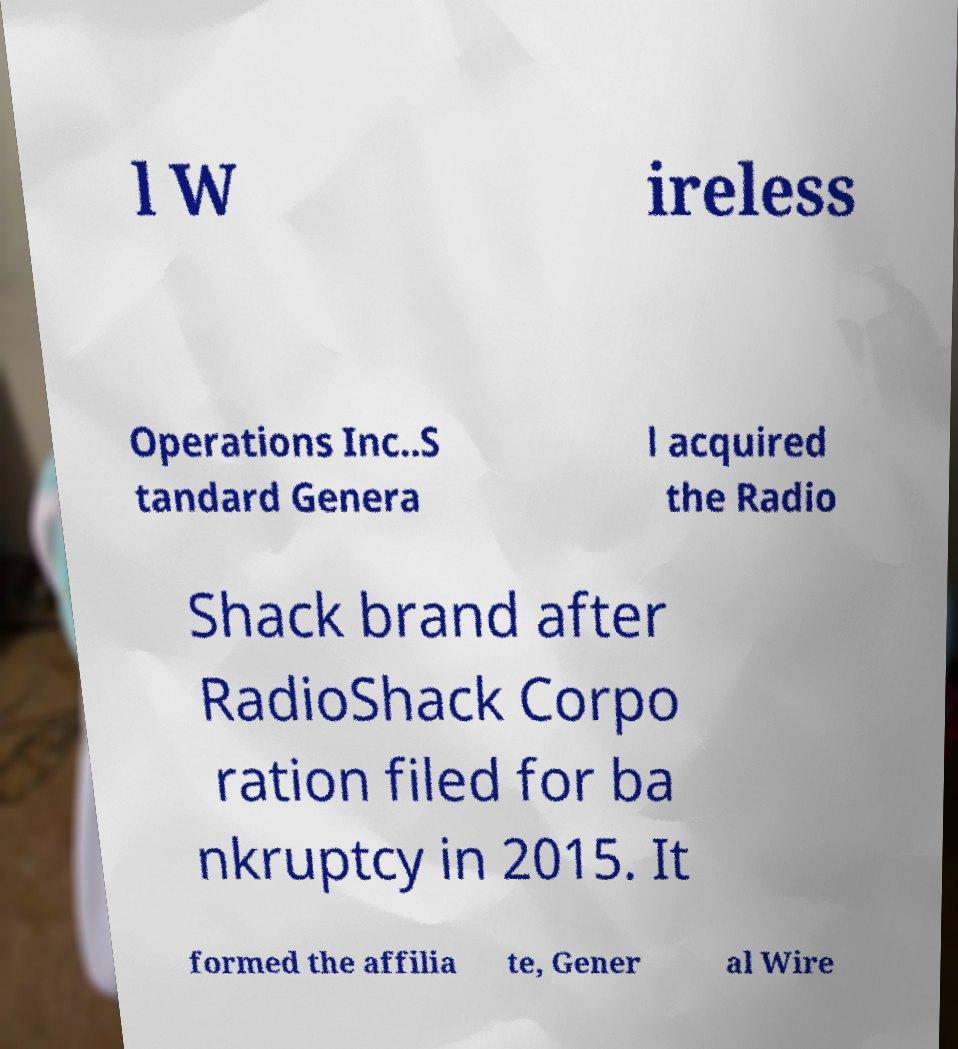Please read and relay the text visible in this image. What does it say? l W ireless Operations Inc..S tandard Genera l acquired the Radio Shack brand after RadioShack Corpo ration filed for ba nkruptcy in 2015. It formed the affilia te, Gener al Wire 